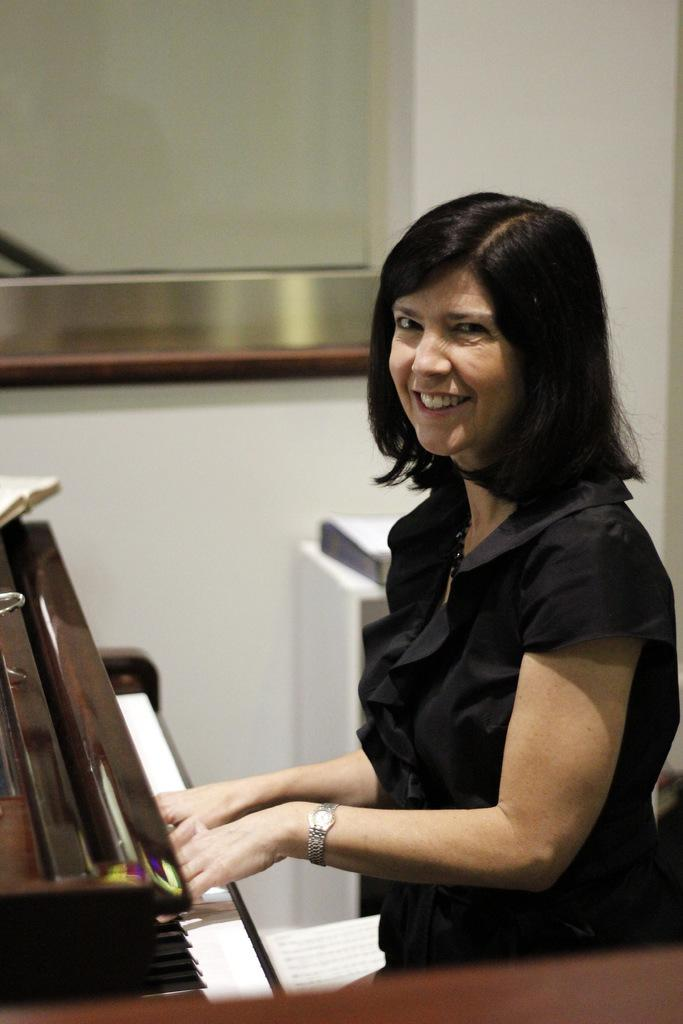What is the woman in the image doing? The woman is playing a piano. What is the woman's facial expression in the image? The woman is smiling. What accessory is the woman wearing in the image? The woman is wearing a watch. What can be seen in the background of the image? There is a wall in the background of the image. What verse is the woman reciting while playing the piano in the image? There is no indication in the image that the woman is reciting a verse while playing the piano. 